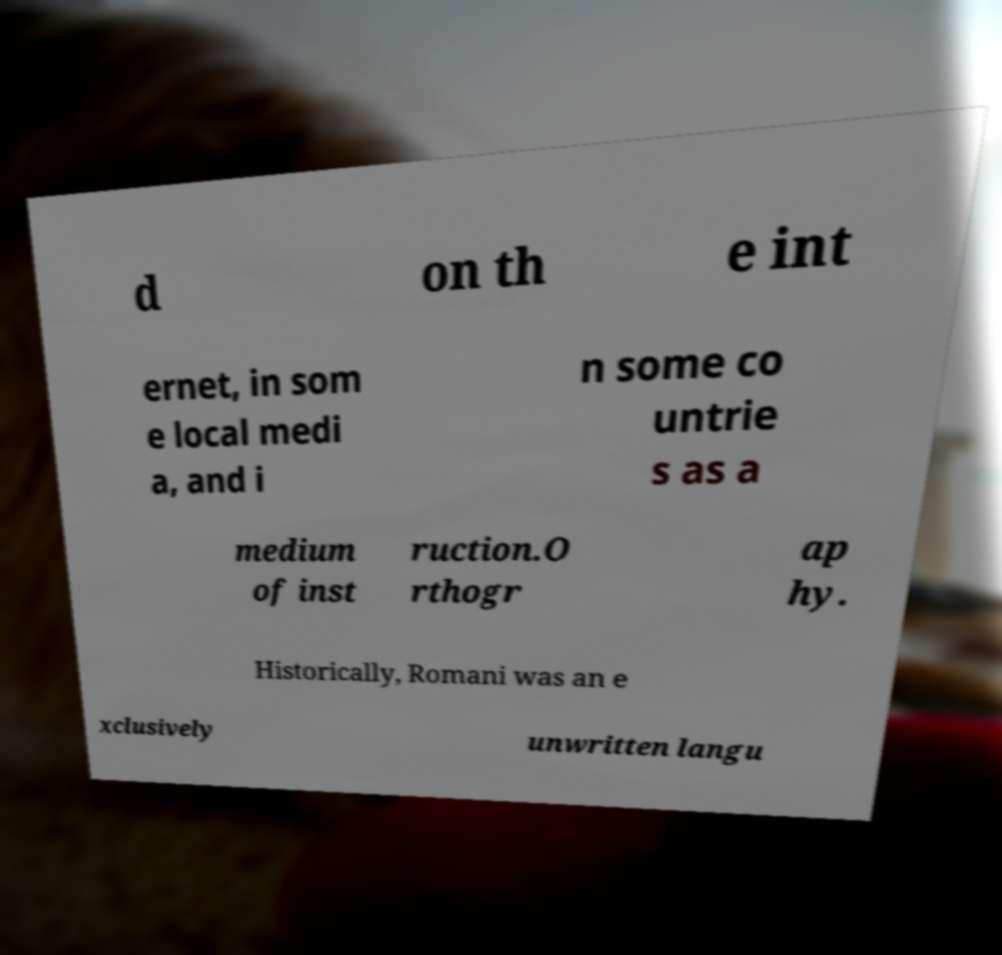Please read and relay the text visible in this image. What does it say? d on th e int ernet, in som e local medi a, and i n some co untrie s as a medium of inst ruction.O rthogr ap hy. Historically, Romani was an e xclusively unwritten langu 